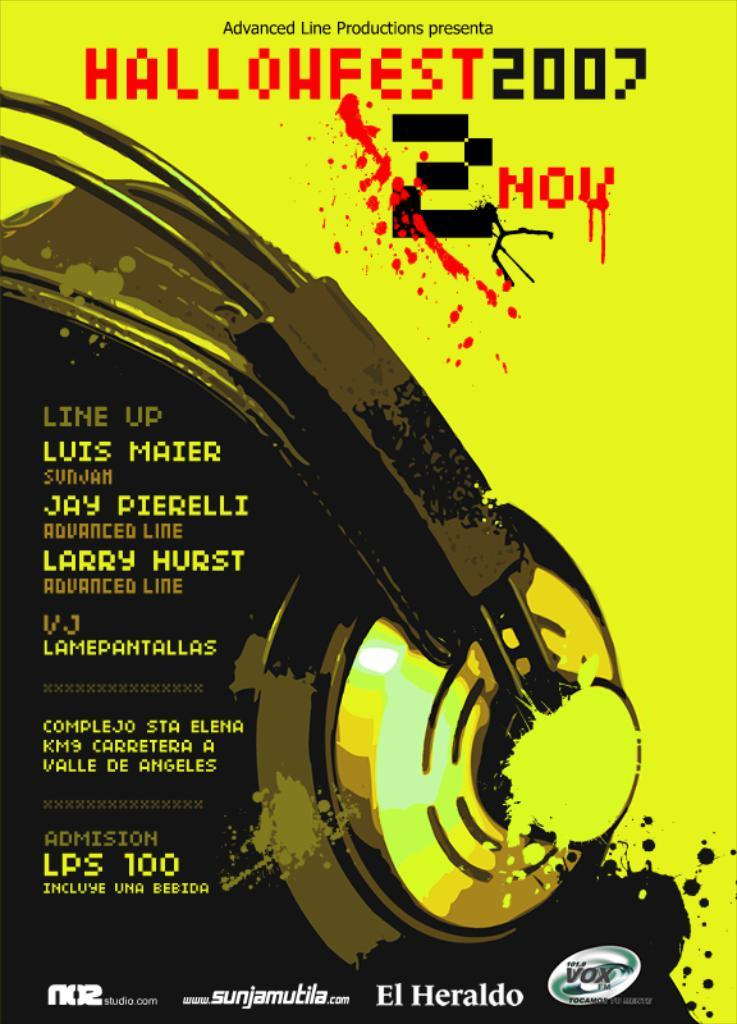Provide a one-sentence caption for the provided image. A poster for a Haloween event occuring in 2007. 